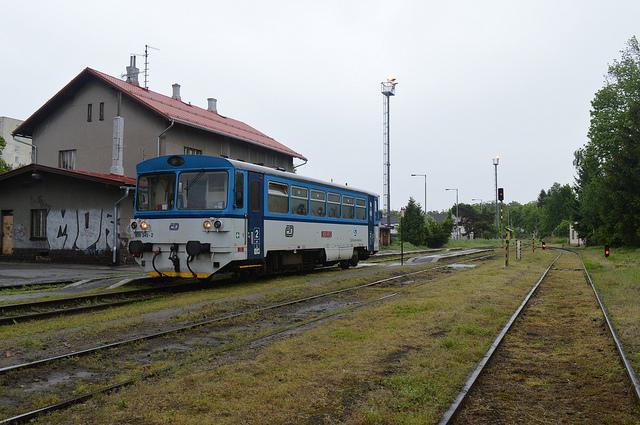Is this train parked in a station?
Write a very short answer. Yes. What colors are on the front of the train?
Be succinct. Blue and white. Why would people come to this place?
Give a very brief answer. Ride train. What is covering the ground?
Quick response, please. Grass. How many cars does this train have?
Give a very brief answer. 1. Is this a passenger train?
Be succinct. Yes. Is there a tower present in this photo?
Write a very short answer. Yes. What is the main color of the train?
Answer briefly. Blue. 